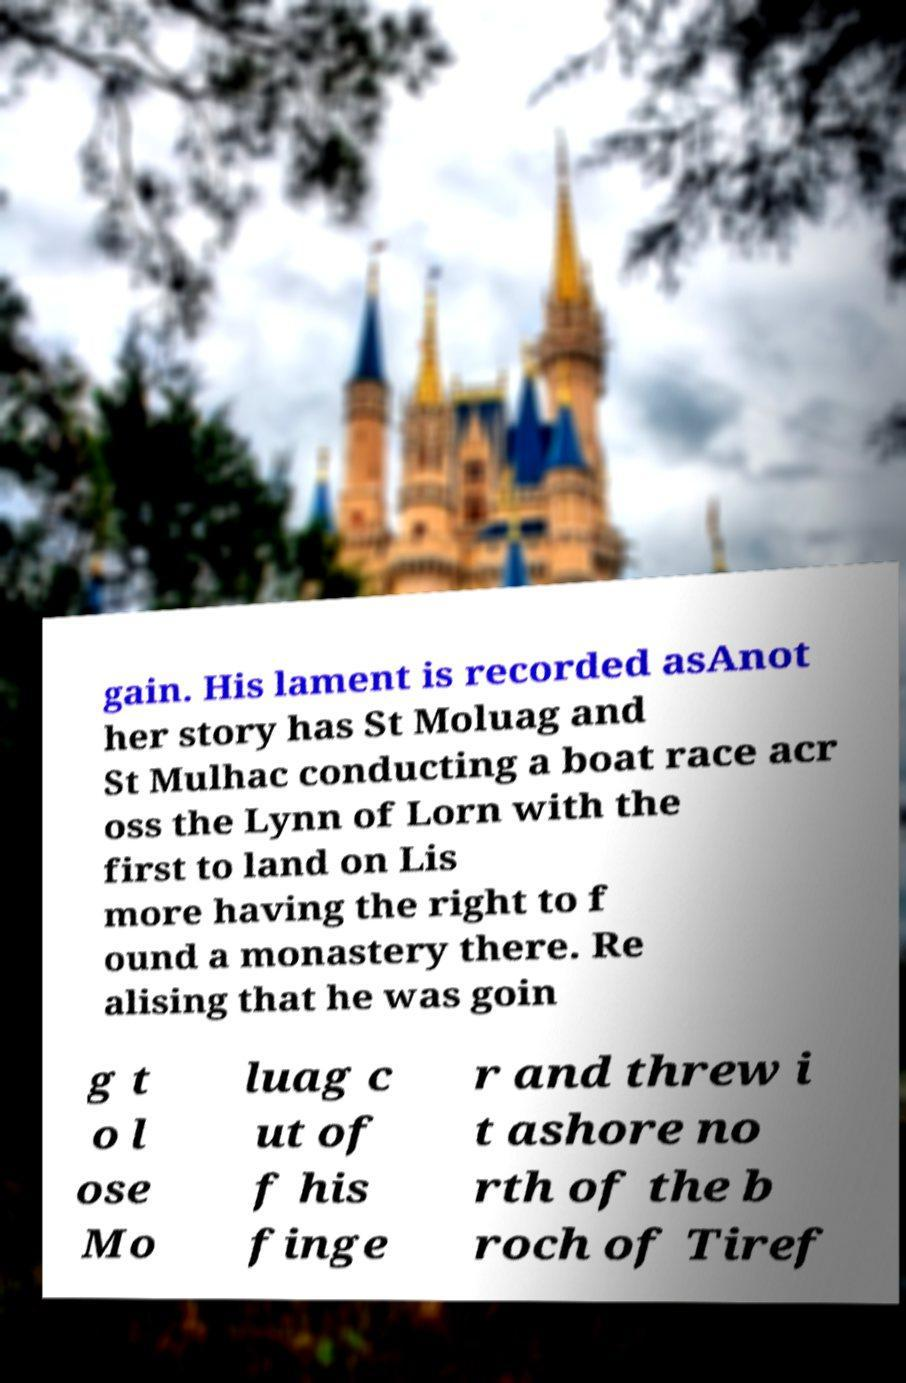Can you read and provide the text displayed in the image?This photo seems to have some interesting text. Can you extract and type it out for me? gain. His lament is recorded asAnot her story has St Moluag and St Mulhac conducting a boat race acr oss the Lynn of Lorn with the first to land on Lis more having the right to f ound a monastery there. Re alising that he was goin g t o l ose Mo luag c ut of f his finge r and threw i t ashore no rth of the b roch of Tiref 